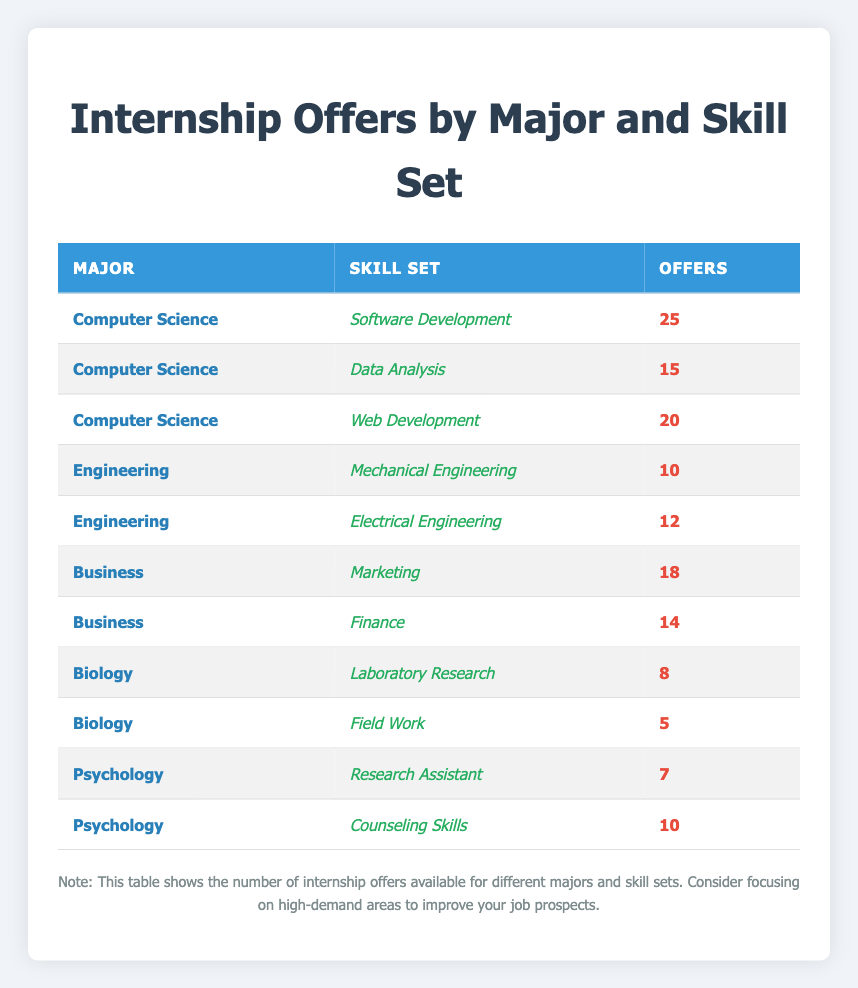What major has the highest number of internship offers? By examining the table, the column for "Offers" shows the number of internship offers for each major. The highest value is 25, which corresponds to "Computer Science."
Answer: Computer Science How many internship offers are there for Business? To find the total number of internship offers for the "Business" major, we look at the relevant rows. There are 18 offers for "Marketing" and 14 offers for "Finance." Adding these gives 18 + 14 = 32.
Answer: 32 Is it true that there are more internship offers in Engineering than in Psychology? We check the total offers for "Engineering" and "Psychology." Engineering has 10 (Mechanical) + 12 (Electrical) = 22, while Psychology has 7 (Research Assistant) + 10 (Counseling Skills) = 17. Since 22 > 17, the statement is true.
Answer: Yes What is the average number of internship offers for Computer Science? The total offers for Computer Science are 25 (Software Development) + 15 (Data Analysis) + 20 (Web Development) = 60. There are 3 skill sets, so the average is 60 / 3 = 20.
Answer: 20 Which skill set in Biology has the lowest number of internship offers? Looking at the "Offers" column for the "Biology" major, 8 offers for "Laboratory Research" and 5 offers for "Field Work" are listed. Since 5 is lower than 8, "Field Work" has the lowest offers.
Answer: Field Work What are the total internship offers for all majors combined? We need to sum all the offers listed in the table. Adding up: 25 + 15 + 20 + 10 + 12 + 18 + 14 + 8 + 5 + 7 + 10 =  139.
Answer: 139 Is there any skill set in Business with fewer than 15 offers? Checking the "Business" rows, Marketing has 18 offers (greater than 15), and Finance has 14 offers (less than 15). This indicates there is at least one skill set with fewer than 15 offers.
Answer: Yes What is the difference in internship offers between the highest and lowest skill sets in the table? The highest offer is 25 for "Software Development" (Computer Science), and the lowest is 5 for "Field Work" (Biology). The difference is 25 - 5 = 20.
Answer: 20 Which major has the most varied skill sets based on the number of internship offers? Assessing the variances, Computer Science has 3 different skill sets (offers: 25, 15, 20) which show a range of 10 (max 25 - min 15). Business has a range of 4 (18 - 14), and other majors have even smaller ranges. Thus, Computer Science has the most varied skill sets.
Answer: Computer Science 